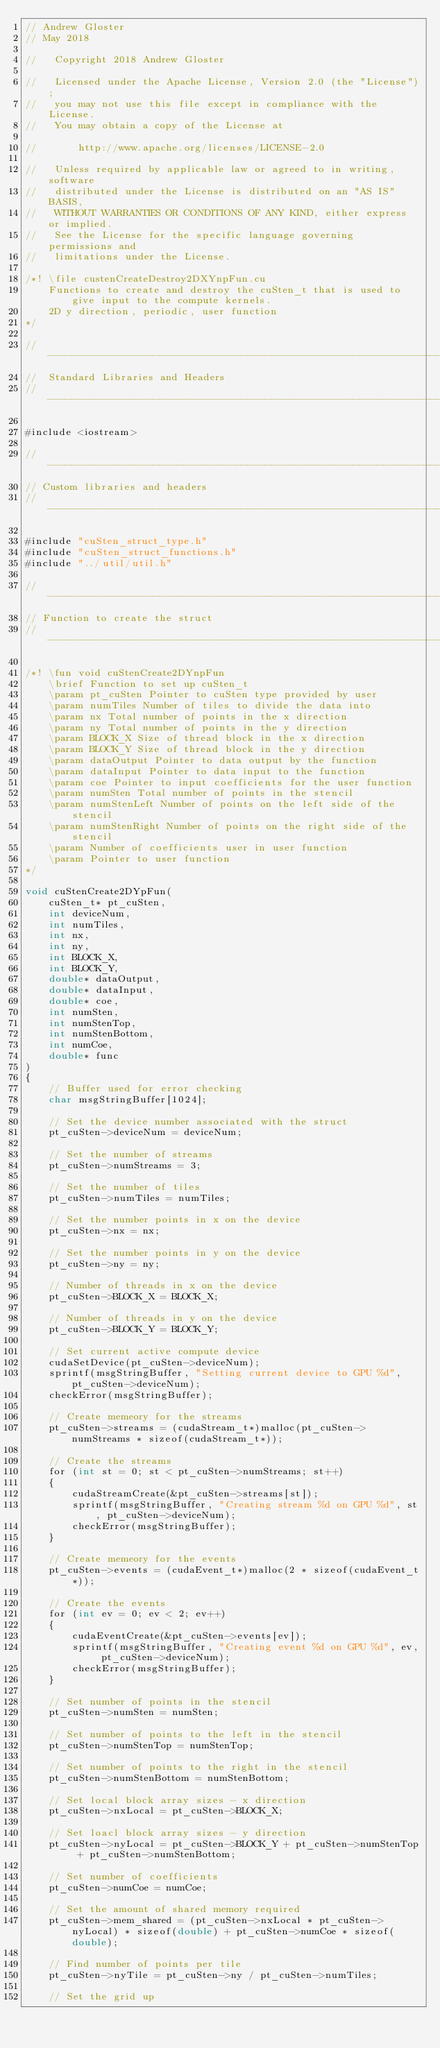<code> <loc_0><loc_0><loc_500><loc_500><_Cuda_>// Andrew Gloster
// May 2018

//   Copyright 2018 Andrew Gloster

//   Licensed under the Apache License, Version 2.0 (the "License");
//   you may not use this file except in compliance with the License.
//   You may obtain a copy of the License at

//       http://www.apache.org/licenses/LICENSE-2.0

//   Unless required by applicable law or agreed to in writing, software
//   distributed under the License is distributed on an "AS IS" BASIS,
//   WITHOUT WARRANTIES OR CONDITIONS OF ANY KIND, either express or implied.
//   See the License for the specific language governing permissions and
//   limitations under the License.

/*! \file custenCreateDestroy2DXYnpFun.cu
    Functions to create and destroy the cuSten_t that is used to give input to the compute kernels. 
    2D y direction, periodic, user function
*/

// ---------------------------------------------------------------------
//  Standard Libraries and Headers
// ---------------------------------------------------------------------

#include <iostream>

// ---------------------------------------------------------------------
// Custom libraries and headers
// ---------------------------------------------------------------------

#include "cuSten_struct_type.h"
#include "cuSten_struct_functions.h"
#include "../util/util.h"

// ---------------------------------------------------------------------
// Function to create the struct
// ---------------------------------------------------------------------

/*! \fun void cuStenCreate2DYnpFun
    \brief Function to set up cuSten_t
    \param pt_cuSten Pointer to cuSten type provided by user
	\param numTiles Number of tiles to divide the data into
	\param nx Total number of points in the x direction 
	\param ny Total number of points in the y direction 
	\param BLOCK_X Size of thread block in the x direction
	\param BLOCK_Y Size of thread block in the y direction
    \param dataOutput Pointer to data output by the function
	\param dataInput Pointer to data input to the function    
	\param coe Pointer to input coefficients for the user function
	\param numSten Total number of points in the stencil
	\param numStenLeft Number of points on the left side of the stencil
	\param numStenRight Number of points on the right side of the stencil
	\param Number of coefficients user in user function
	\param Pointer to user function
*/

void cuStenCreate2DYpFun(
	cuSten_t* pt_cuSten,
	int deviceNum,
	int numTiles,
	int nx,
	int ny,
	int BLOCK_X,
	int BLOCK_Y,
	double* dataOutput,
	double* dataInput,
	double* coe,
	int numSten,
	int numStenTop,
	int numStenBottom,
	int numCoe,
	double* func	
) 
{
	// Buffer used for error checking
	char msgStringBuffer[1024];

	// Set the device number associated with the struct
  	pt_cuSten->deviceNum = deviceNum;

  	// Set the number of streams
  	pt_cuSten->numStreams = 3;

  	// Set the number of tiles
  	pt_cuSten->numTiles = numTiles;

  	// Set the number points in x on the device
  	pt_cuSten->nx = nx;

  	// Set the number points in y on the device
  	pt_cuSten->ny = ny;

  	// Number of threads in x on the device
	pt_cuSten->BLOCK_X = BLOCK_X;

  	// Number of threads in y on the device
	pt_cuSten->BLOCK_Y = BLOCK_Y;

	// Set current active compute device
	cudaSetDevice(pt_cuSten->deviceNum);
	sprintf(msgStringBuffer, "Setting current device to GPU %d", pt_cuSten->deviceNum);
	checkError(msgStringBuffer);	

	// Create memeory for the streams
	pt_cuSten->streams = (cudaStream_t*)malloc(pt_cuSten->numStreams * sizeof(cudaStream_t*));

	// Create the streams
	for (int st = 0; st < pt_cuSten->numStreams; st++)
	{
		cudaStreamCreate(&pt_cuSten->streams[st]);
		sprintf(msgStringBuffer, "Creating stream %d on GPU %d", st, pt_cuSten->deviceNum);
		checkError(msgStringBuffer);	
	}

	// Create memeory for the events
	pt_cuSten->events = (cudaEvent_t*)malloc(2 * sizeof(cudaEvent_t*));

	// Create the events
	for (int ev = 0; ev < 2; ev++)
	{
		cudaEventCreate(&pt_cuSten->events[ev]);
		sprintf(msgStringBuffer, "Creating event %d on GPU %d", ev, pt_cuSten->deviceNum);
		checkError(msgStringBuffer);
	}

	// Set number of points in the stencil
	pt_cuSten->numSten = numSten;

	// Set number of points to the left in the stencil
	pt_cuSten->numStenTop = numStenTop;

	// Set number of points to the right in the stencil
	pt_cuSten->numStenBottom = numStenBottom;

	// Set local block array sizes - x direction
	pt_cuSten->nxLocal = pt_cuSten->BLOCK_X;

	// Set loacl block array sizes - y direction
	pt_cuSten->nyLocal = pt_cuSten->BLOCK_Y + pt_cuSten->numStenTop + pt_cuSten->numStenBottom;

	// Set number of coefficients
	pt_cuSten->numCoe = numCoe;

	// Set the amount of shared memory required
	pt_cuSten->mem_shared = (pt_cuSten->nxLocal * pt_cuSten->nyLocal) * sizeof(double) + pt_cuSten->numCoe * sizeof(double);

	// Find number of points per tile
	pt_cuSten->nyTile = pt_cuSten->ny / pt_cuSten->numTiles;	

	// Set the grid up</code> 